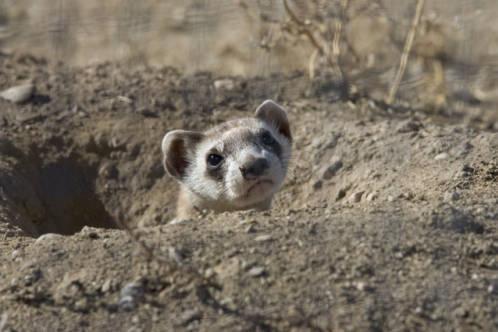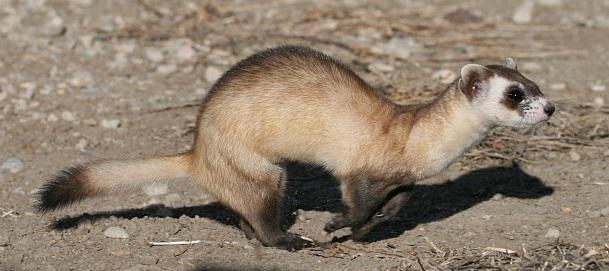The first image is the image on the left, the second image is the image on the right. For the images displayed, is the sentence "One of the animal's tail is curved" factually correct? Answer yes or no. No. The first image is the image on the left, the second image is the image on the right. For the images shown, is this caption "The animal in one of the images is in side profile" true? Answer yes or no. Yes. 